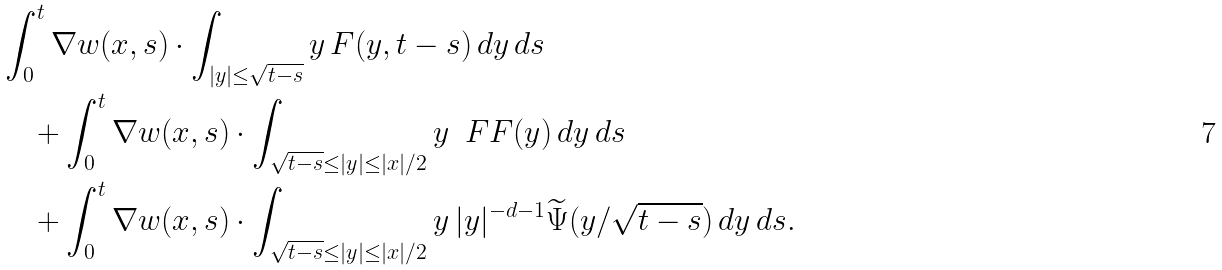<formula> <loc_0><loc_0><loc_500><loc_500>& \int _ { 0 } ^ { t } \nabla w ( x , s ) \cdot \int _ { | y | \leq \sqrt { t - s } } y \, F ( y , t - s ) \, d y \, d s \\ & \quad + \int _ { 0 } ^ { t } \nabla w ( x , s ) \cdot \int _ { \sqrt { t - s } \leq | y | \leq | x | / 2 } y \, \ F F ( y ) \, d y \, d s \\ & \quad + \int _ { 0 } ^ { t } \nabla w ( x , s ) \cdot \int _ { \sqrt { t - s } \leq | y | \leq | x | / 2 } y \, | y | ^ { - d - 1 } \widetilde { \Psi } ( y / \sqrt { t - s } ) \, d y \, d s .</formula> 